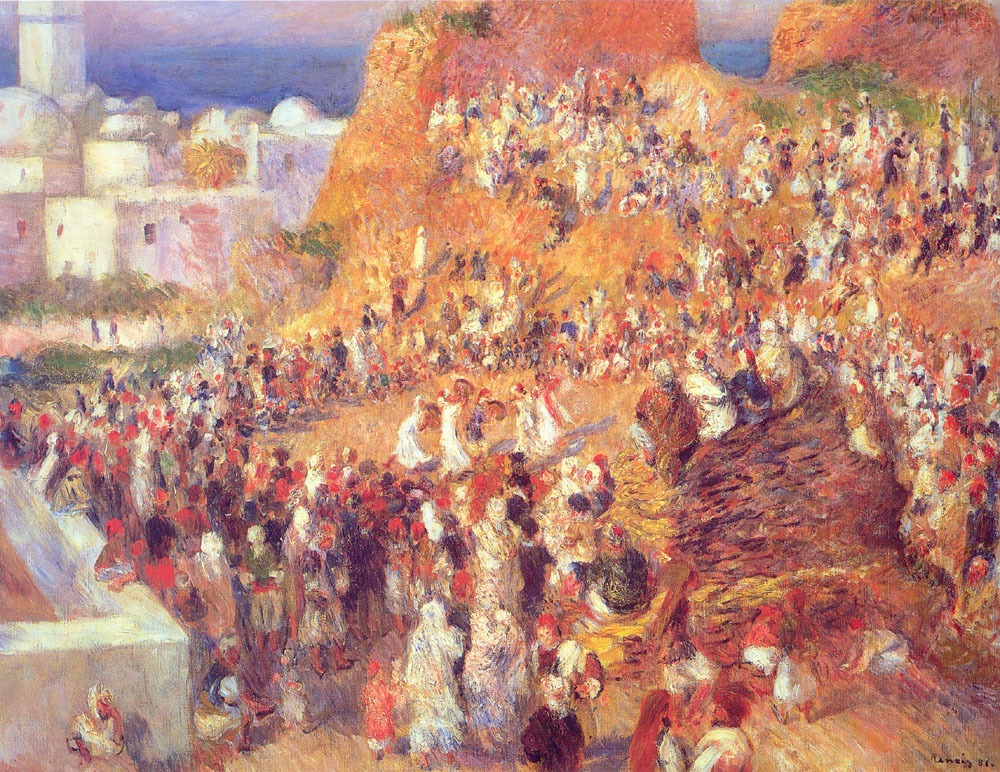Explain the visual content of the image in great detail. The image is a vibrant impressionist painting depicting a lively market scene set against the backdrop of what appears to be a Mediterranean town, based on the architectural styles visible. The canvas is awash with warm, sun-kissed hues: bright reds, deep oranges, and soft yellows, suggesting the time could be either late afternoon or early evening. The brushwork is loose yet deliberate, capturing the essence of movement within the bustling crowd. The scene is teeming with numerous figures engaged in various activities typical of a market, such as conversing, walking, and bargaining. Buildings with discernible features like windows and balconies rise in the background, while the foreground is occupied by an array of indistinct yet energetic marketgoers. The painting's dynamic feel is further exaggerated by the thick application of paint, creating a rich texture that invites the viewer to feel the vibrancy and chaotic harmony of the scene. 